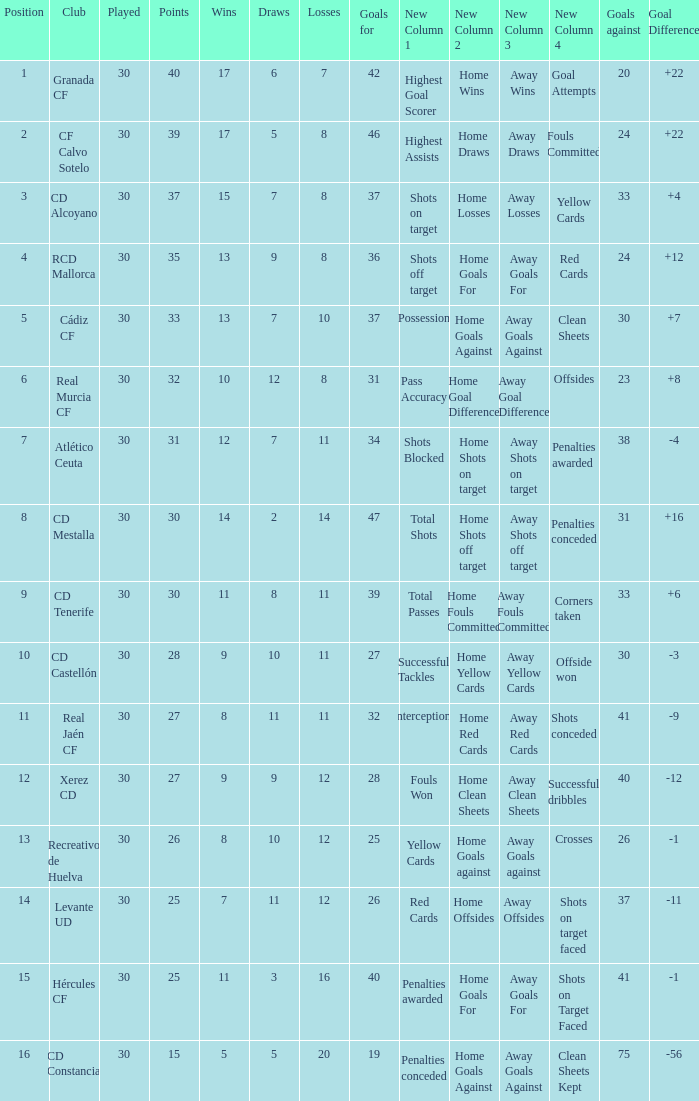Which Played has a Club of atlético ceuta, and less than 11 Losses? None. 